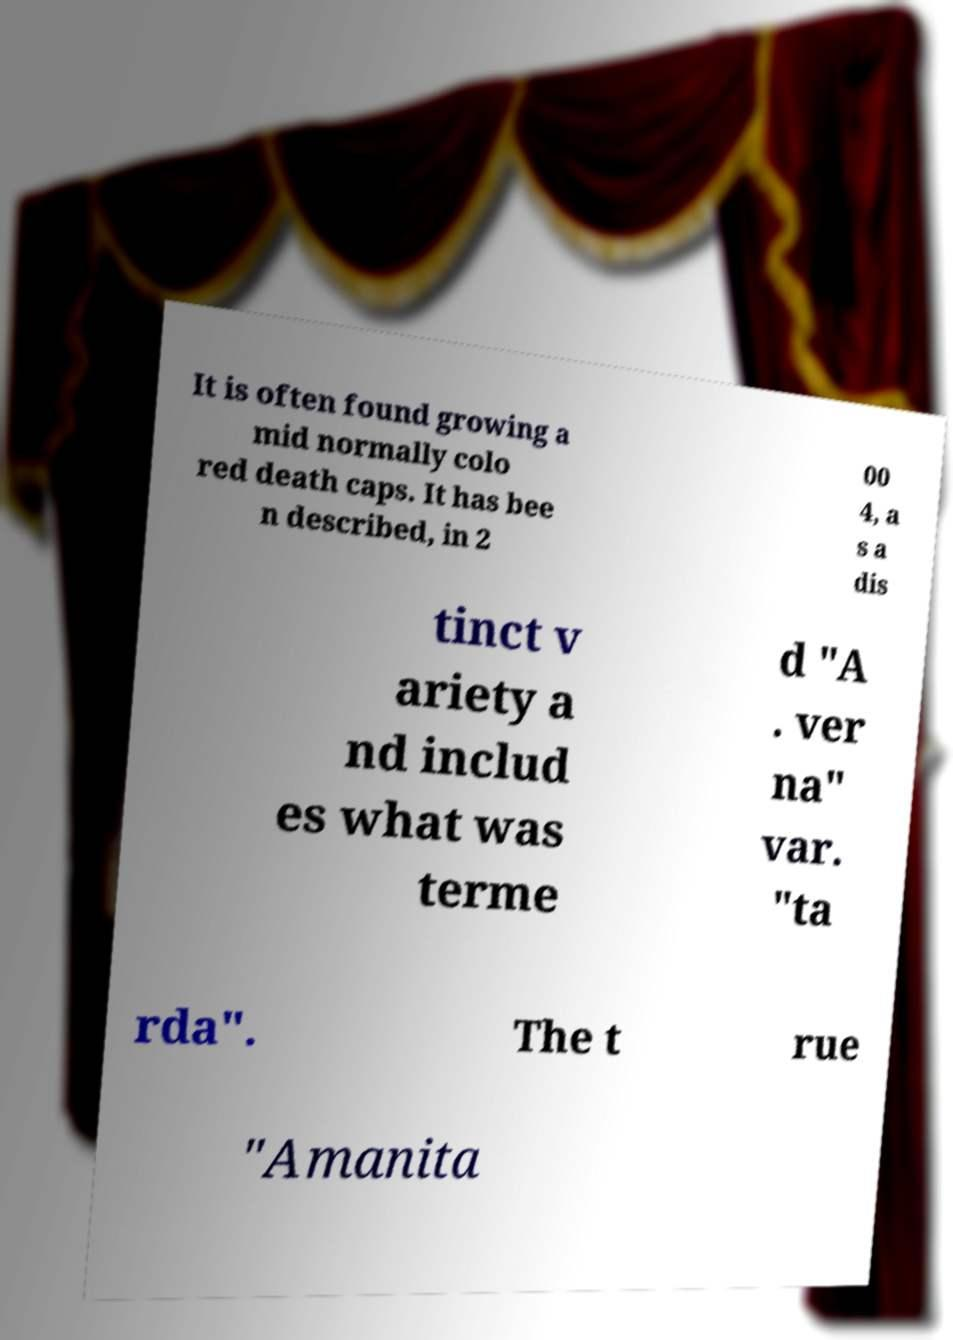What messages or text are displayed in this image? I need them in a readable, typed format. It is often found growing a mid normally colo red death caps. It has bee n described, in 2 00 4, a s a dis tinct v ariety a nd includ es what was terme d "A . ver na" var. "ta rda". The t rue "Amanita 